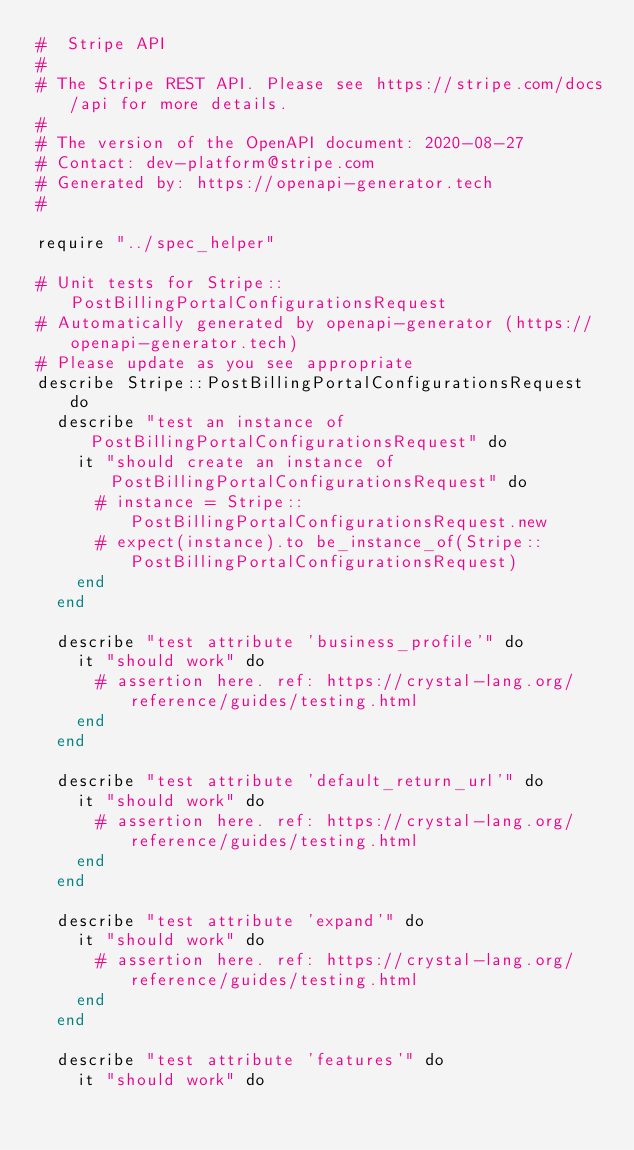<code> <loc_0><loc_0><loc_500><loc_500><_Crystal_>#  Stripe API
#
# The Stripe REST API. Please see https://stripe.com/docs/api for more details.
#
# The version of the OpenAPI document: 2020-08-27
# Contact: dev-platform@stripe.com
# Generated by: https://openapi-generator.tech
#

require "../spec_helper"

# Unit tests for Stripe::PostBillingPortalConfigurationsRequest
# Automatically generated by openapi-generator (https://openapi-generator.tech)
# Please update as you see appropriate
describe Stripe::PostBillingPortalConfigurationsRequest do
  describe "test an instance of PostBillingPortalConfigurationsRequest" do
    it "should create an instance of PostBillingPortalConfigurationsRequest" do
      # instance = Stripe::PostBillingPortalConfigurationsRequest.new
      # expect(instance).to be_instance_of(Stripe::PostBillingPortalConfigurationsRequest)
    end
  end

  describe "test attribute 'business_profile'" do
    it "should work" do
      # assertion here. ref: https://crystal-lang.org/reference/guides/testing.html
    end
  end

  describe "test attribute 'default_return_url'" do
    it "should work" do
      # assertion here. ref: https://crystal-lang.org/reference/guides/testing.html
    end
  end

  describe "test attribute 'expand'" do
    it "should work" do
      # assertion here. ref: https://crystal-lang.org/reference/guides/testing.html
    end
  end

  describe "test attribute 'features'" do
    it "should work" do</code> 